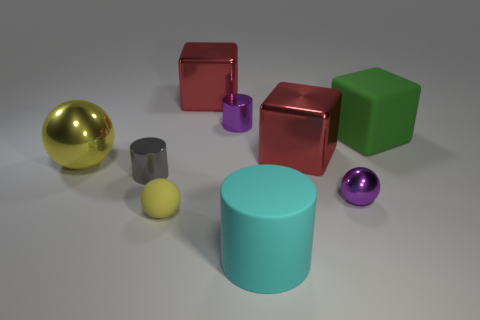Is the number of small gray objects less than the number of spheres?
Give a very brief answer. Yes. Is there any other thing that has the same color as the small shiny sphere?
Give a very brief answer. Yes. There is a gray shiny object that is in front of the green matte object; what size is it?
Your answer should be compact. Small. Is the number of blue objects greater than the number of small purple metal cylinders?
Ensure brevity in your answer.  No. What is the material of the small gray thing?
Offer a very short reply. Metal. What number of other objects are there of the same material as the large yellow ball?
Offer a terse response. 5. What number of big metal cubes are there?
Offer a very short reply. 2. There is a cyan thing that is the same shape as the tiny gray object; what material is it?
Provide a short and direct response. Rubber. Are the tiny purple thing right of the large rubber cylinder and the large cyan thing made of the same material?
Offer a very short reply. No. Is the number of rubber things to the right of the large yellow metal ball greater than the number of green things that are on the left side of the tiny yellow matte thing?
Provide a succinct answer. Yes. 